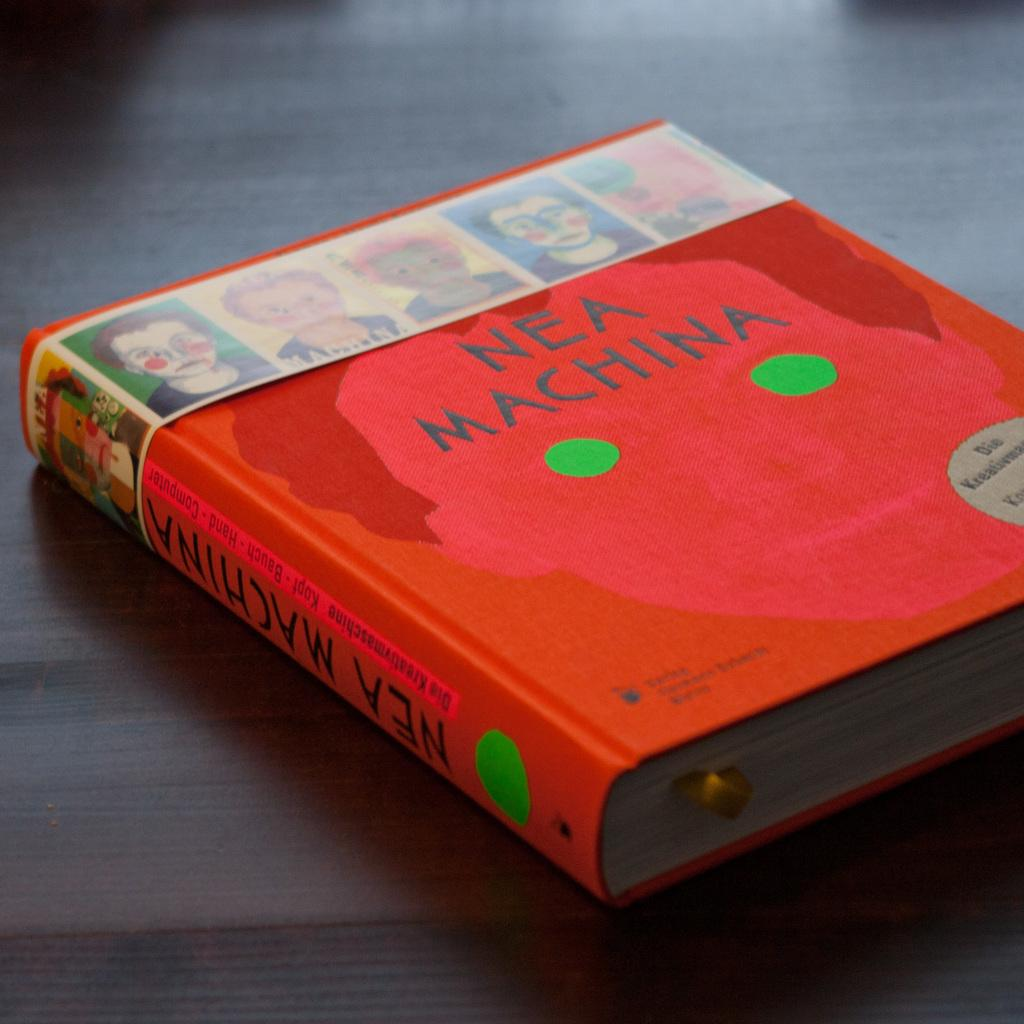<image>
Summarize the visual content of the image. A book called Nea Machina sits on a table. 